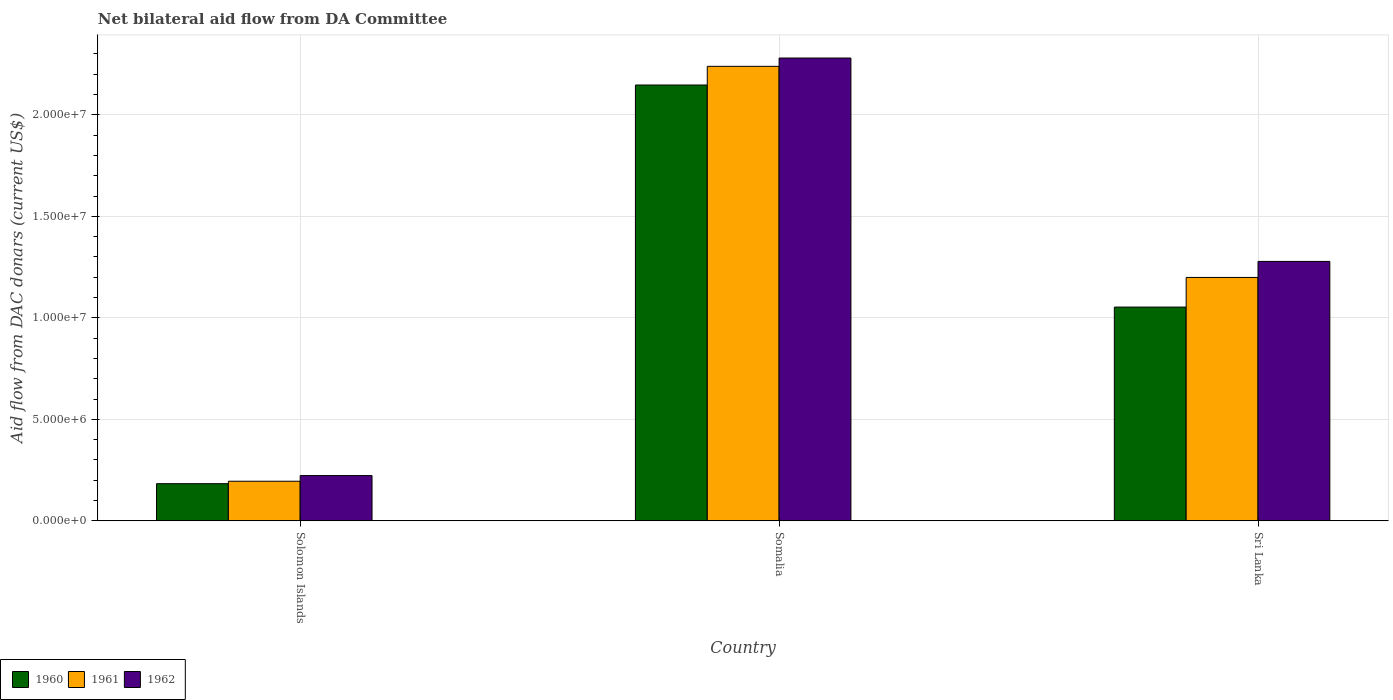Are the number of bars on each tick of the X-axis equal?
Give a very brief answer. Yes. How many bars are there on the 3rd tick from the left?
Your answer should be very brief. 3. What is the label of the 1st group of bars from the left?
Keep it short and to the point. Solomon Islands. What is the aid flow in in 1961 in Solomon Islands?
Offer a very short reply. 1.95e+06. Across all countries, what is the maximum aid flow in in 1961?
Give a very brief answer. 2.24e+07. Across all countries, what is the minimum aid flow in in 1962?
Your answer should be very brief. 2.23e+06. In which country was the aid flow in in 1961 maximum?
Your response must be concise. Somalia. In which country was the aid flow in in 1961 minimum?
Keep it short and to the point. Solomon Islands. What is the total aid flow in in 1962 in the graph?
Your answer should be compact. 3.78e+07. What is the difference between the aid flow in in 1962 in Somalia and that in Sri Lanka?
Give a very brief answer. 1.00e+07. What is the difference between the aid flow in in 1960 in Solomon Islands and the aid flow in in 1962 in Sri Lanka?
Provide a succinct answer. -1.10e+07. What is the average aid flow in in 1961 per country?
Ensure brevity in your answer.  1.21e+07. What is the difference between the aid flow in of/in 1962 and aid flow in of/in 1960 in Sri Lanka?
Make the answer very short. 2.25e+06. What is the ratio of the aid flow in in 1962 in Somalia to that in Sri Lanka?
Offer a very short reply. 1.78. Is the difference between the aid flow in in 1962 in Solomon Islands and Sri Lanka greater than the difference between the aid flow in in 1960 in Solomon Islands and Sri Lanka?
Your answer should be very brief. No. What is the difference between the highest and the second highest aid flow in in 1960?
Make the answer very short. 1.96e+07. What is the difference between the highest and the lowest aid flow in in 1960?
Your answer should be compact. 1.96e+07. In how many countries, is the aid flow in in 1962 greater than the average aid flow in in 1962 taken over all countries?
Your answer should be compact. 2. What does the 2nd bar from the left in Somalia represents?
Keep it short and to the point. 1961. What is the difference between two consecutive major ticks on the Y-axis?
Your response must be concise. 5.00e+06. Are the values on the major ticks of Y-axis written in scientific E-notation?
Keep it short and to the point. Yes. Does the graph contain any zero values?
Your answer should be compact. No. Does the graph contain grids?
Keep it short and to the point. Yes. How are the legend labels stacked?
Provide a short and direct response. Horizontal. What is the title of the graph?
Offer a very short reply. Net bilateral aid flow from DA Committee. What is the label or title of the X-axis?
Give a very brief answer. Country. What is the label or title of the Y-axis?
Give a very brief answer. Aid flow from DAC donars (current US$). What is the Aid flow from DAC donars (current US$) of 1960 in Solomon Islands?
Offer a terse response. 1.83e+06. What is the Aid flow from DAC donars (current US$) of 1961 in Solomon Islands?
Your answer should be compact. 1.95e+06. What is the Aid flow from DAC donars (current US$) of 1962 in Solomon Islands?
Offer a very short reply. 2.23e+06. What is the Aid flow from DAC donars (current US$) of 1960 in Somalia?
Your answer should be compact. 2.15e+07. What is the Aid flow from DAC donars (current US$) in 1961 in Somalia?
Give a very brief answer. 2.24e+07. What is the Aid flow from DAC donars (current US$) of 1962 in Somalia?
Provide a succinct answer. 2.28e+07. What is the Aid flow from DAC donars (current US$) of 1960 in Sri Lanka?
Make the answer very short. 1.05e+07. What is the Aid flow from DAC donars (current US$) in 1961 in Sri Lanka?
Your response must be concise. 1.20e+07. What is the Aid flow from DAC donars (current US$) of 1962 in Sri Lanka?
Offer a terse response. 1.28e+07. Across all countries, what is the maximum Aid flow from DAC donars (current US$) of 1960?
Ensure brevity in your answer.  2.15e+07. Across all countries, what is the maximum Aid flow from DAC donars (current US$) in 1961?
Ensure brevity in your answer.  2.24e+07. Across all countries, what is the maximum Aid flow from DAC donars (current US$) of 1962?
Offer a very short reply. 2.28e+07. Across all countries, what is the minimum Aid flow from DAC donars (current US$) in 1960?
Your answer should be compact. 1.83e+06. Across all countries, what is the minimum Aid flow from DAC donars (current US$) in 1961?
Your answer should be compact. 1.95e+06. Across all countries, what is the minimum Aid flow from DAC donars (current US$) of 1962?
Offer a terse response. 2.23e+06. What is the total Aid flow from DAC donars (current US$) of 1960 in the graph?
Ensure brevity in your answer.  3.38e+07. What is the total Aid flow from DAC donars (current US$) in 1961 in the graph?
Offer a terse response. 3.63e+07. What is the total Aid flow from DAC donars (current US$) in 1962 in the graph?
Your answer should be very brief. 3.78e+07. What is the difference between the Aid flow from DAC donars (current US$) of 1960 in Solomon Islands and that in Somalia?
Provide a succinct answer. -1.96e+07. What is the difference between the Aid flow from DAC donars (current US$) of 1961 in Solomon Islands and that in Somalia?
Give a very brief answer. -2.04e+07. What is the difference between the Aid flow from DAC donars (current US$) of 1962 in Solomon Islands and that in Somalia?
Your answer should be compact. -2.06e+07. What is the difference between the Aid flow from DAC donars (current US$) in 1960 in Solomon Islands and that in Sri Lanka?
Offer a terse response. -8.70e+06. What is the difference between the Aid flow from DAC donars (current US$) of 1961 in Solomon Islands and that in Sri Lanka?
Your answer should be very brief. -1.00e+07. What is the difference between the Aid flow from DAC donars (current US$) in 1962 in Solomon Islands and that in Sri Lanka?
Your answer should be compact. -1.06e+07. What is the difference between the Aid flow from DAC donars (current US$) in 1960 in Somalia and that in Sri Lanka?
Your response must be concise. 1.09e+07. What is the difference between the Aid flow from DAC donars (current US$) in 1961 in Somalia and that in Sri Lanka?
Provide a succinct answer. 1.04e+07. What is the difference between the Aid flow from DAC donars (current US$) of 1962 in Somalia and that in Sri Lanka?
Provide a short and direct response. 1.00e+07. What is the difference between the Aid flow from DAC donars (current US$) of 1960 in Solomon Islands and the Aid flow from DAC donars (current US$) of 1961 in Somalia?
Keep it short and to the point. -2.06e+07. What is the difference between the Aid flow from DAC donars (current US$) of 1960 in Solomon Islands and the Aid flow from DAC donars (current US$) of 1962 in Somalia?
Make the answer very short. -2.10e+07. What is the difference between the Aid flow from DAC donars (current US$) in 1961 in Solomon Islands and the Aid flow from DAC donars (current US$) in 1962 in Somalia?
Give a very brief answer. -2.08e+07. What is the difference between the Aid flow from DAC donars (current US$) of 1960 in Solomon Islands and the Aid flow from DAC donars (current US$) of 1961 in Sri Lanka?
Your answer should be compact. -1.02e+07. What is the difference between the Aid flow from DAC donars (current US$) of 1960 in Solomon Islands and the Aid flow from DAC donars (current US$) of 1962 in Sri Lanka?
Keep it short and to the point. -1.10e+07. What is the difference between the Aid flow from DAC donars (current US$) in 1961 in Solomon Islands and the Aid flow from DAC donars (current US$) in 1962 in Sri Lanka?
Offer a very short reply. -1.08e+07. What is the difference between the Aid flow from DAC donars (current US$) in 1960 in Somalia and the Aid flow from DAC donars (current US$) in 1961 in Sri Lanka?
Ensure brevity in your answer.  9.48e+06. What is the difference between the Aid flow from DAC donars (current US$) of 1960 in Somalia and the Aid flow from DAC donars (current US$) of 1962 in Sri Lanka?
Your response must be concise. 8.69e+06. What is the difference between the Aid flow from DAC donars (current US$) of 1961 in Somalia and the Aid flow from DAC donars (current US$) of 1962 in Sri Lanka?
Give a very brief answer. 9.61e+06. What is the average Aid flow from DAC donars (current US$) in 1960 per country?
Make the answer very short. 1.13e+07. What is the average Aid flow from DAC donars (current US$) of 1961 per country?
Provide a succinct answer. 1.21e+07. What is the average Aid flow from DAC donars (current US$) in 1962 per country?
Keep it short and to the point. 1.26e+07. What is the difference between the Aid flow from DAC donars (current US$) in 1960 and Aid flow from DAC donars (current US$) in 1962 in Solomon Islands?
Offer a terse response. -4.00e+05. What is the difference between the Aid flow from DAC donars (current US$) of 1961 and Aid flow from DAC donars (current US$) of 1962 in Solomon Islands?
Provide a succinct answer. -2.80e+05. What is the difference between the Aid flow from DAC donars (current US$) in 1960 and Aid flow from DAC donars (current US$) in 1961 in Somalia?
Your answer should be very brief. -9.20e+05. What is the difference between the Aid flow from DAC donars (current US$) of 1960 and Aid flow from DAC donars (current US$) of 1962 in Somalia?
Keep it short and to the point. -1.33e+06. What is the difference between the Aid flow from DAC donars (current US$) of 1961 and Aid flow from DAC donars (current US$) of 1962 in Somalia?
Your answer should be compact. -4.10e+05. What is the difference between the Aid flow from DAC donars (current US$) in 1960 and Aid flow from DAC donars (current US$) in 1961 in Sri Lanka?
Your answer should be very brief. -1.46e+06. What is the difference between the Aid flow from DAC donars (current US$) of 1960 and Aid flow from DAC donars (current US$) of 1962 in Sri Lanka?
Your answer should be very brief. -2.25e+06. What is the difference between the Aid flow from DAC donars (current US$) of 1961 and Aid flow from DAC donars (current US$) of 1962 in Sri Lanka?
Provide a short and direct response. -7.90e+05. What is the ratio of the Aid flow from DAC donars (current US$) in 1960 in Solomon Islands to that in Somalia?
Give a very brief answer. 0.09. What is the ratio of the Aid flow from DAC donars (current US$) in 1961 in Solomon Islands to that in Somalia?
Ensure brevity in your answer.  0.09. What is the ratio of the Aid flow from DAC donars (current US$) of 1962 in Solomon Islands to that in Somalia?
Keep it short and to the point. 0.1. What is the ratio of the Aid flow from DAC donars (current US$) of 1960 in Solomon Islands to that in Sri Lanka?
Give a very brief answer. 0.17. What is the ratio of the Aid flow from DAC donars (current US$) in 1961 in Solomon Islands to that in Sri Lanka?
Your response must be concise. 0.16. What is the ratio of the Aid flow from DAC donars (current US$) in 1962 in Solomon Islands to that in Sri Lanka?
Your response must be concise. 0.17. What is the ratio of the Aid flow from DAC donars (current US$) in 1960 in Somalia to that in Sri Lanka?
Give a very brief answer. 2.04. What is the ratio of the Aid flow from DAC donars (current US$) of 1961 in Somalia to that in Sri Lanka?
Make the answer very short. 1.87. What is the ratio of the Aid flow from DAC donars (current US$) of 1962 in Somalia to that in Sri Lanka?
Ensure brevity in your answer.  1.78. What is the difference between the highest and the second highest Aid flow from DAC donars (current US$) of 1960?
Make the answer very short. 1.09e+07. What is the difference between the highest and the second highest Aid flow from DAC donars (current US$) in 1961?
Offer a terse response. 1.04e+07. What is the difference between the highest and the second highest Aid flow from DAC donars (current US$) of 1962?
Your response must be concise. 1.00e+07. What is the difference between the highest and the lowest Aid flow from DAC donars (current US$) in 1960?
Ensure brevity in your answer.  1.96e+07. What is the difference between the highest and the lowest Aid flow from DAC donars (current US$) of 1961?
Make the answer very short. 2.04e+07. What is the difference between the highest and the lowest Aid flow from DAC donars (current US$) of 1962?
Give a very brief answer. 2.06e+07. 